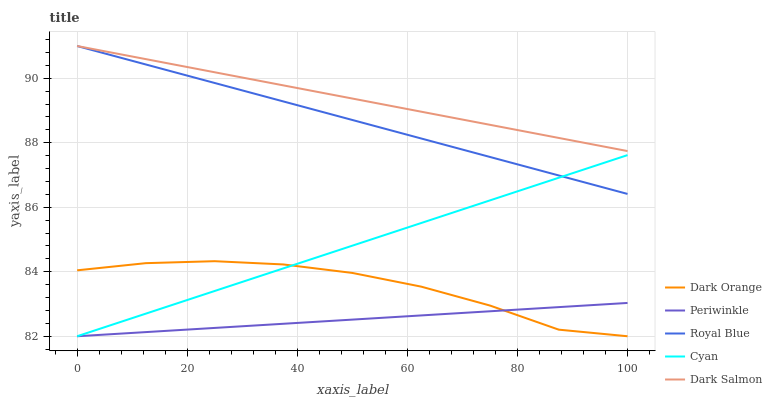Does Cyan have the minimum area under the curve?
Answer yes or no. No. Does Cyan have the maximum area under the curve?
Answer yes or no. No. Is Cyan the smoothest?
Answer yes or no. No. Is Cyan the roughest?
Answer yes or no. No. Does Dark Salmon have the lowest value?
Answer yes or no. No. Does Cyan have the highest value?
Answer yes or no. No. Is Dark Orange less than Dark Salmon?
Answer yes or no. Yes. Is Royal Blue greater than Periwinkle?
Answer yes or no. Yes. Does Dark Orange intersect Dark Salmon?
Answer yes or no. No. 